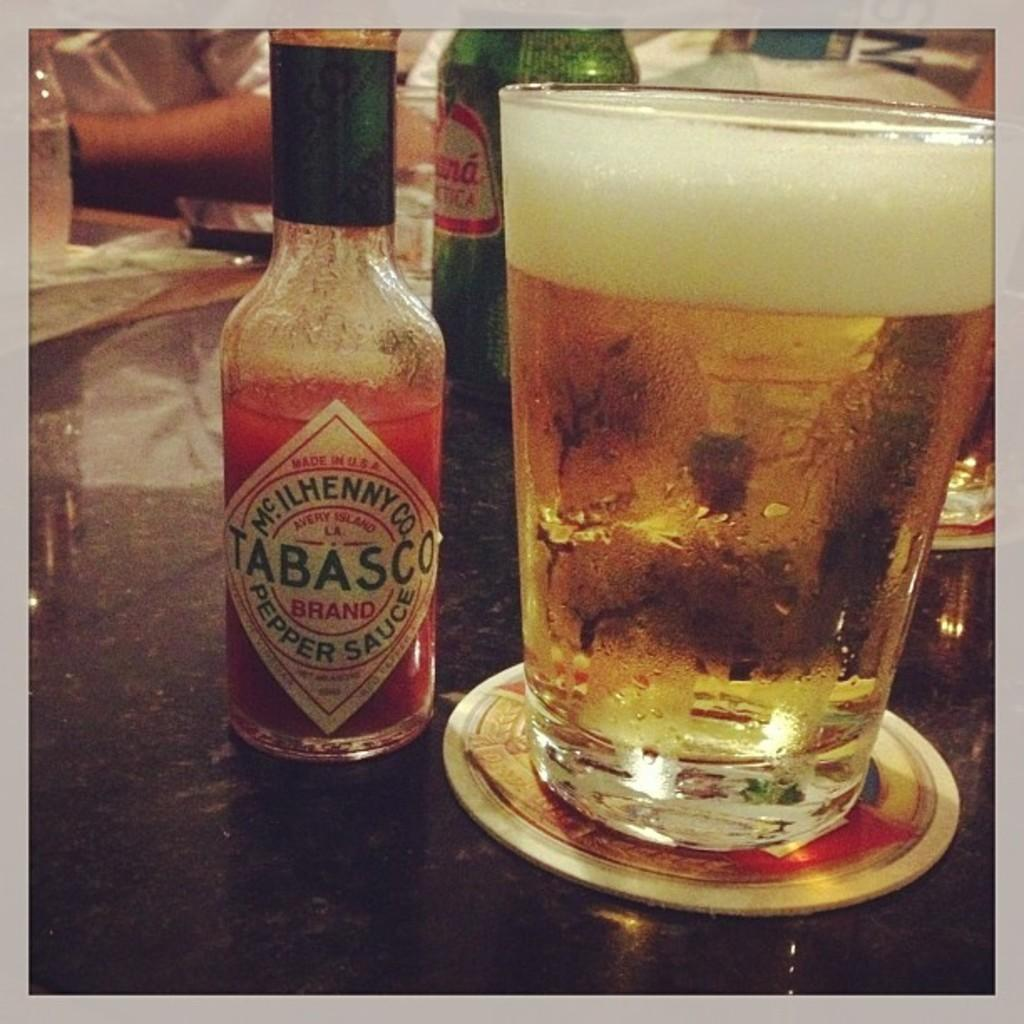<image>
Offer a succinct explanation of the picture presented. A bottle of Tabasco sauce is on a table next to a glass of beer. 